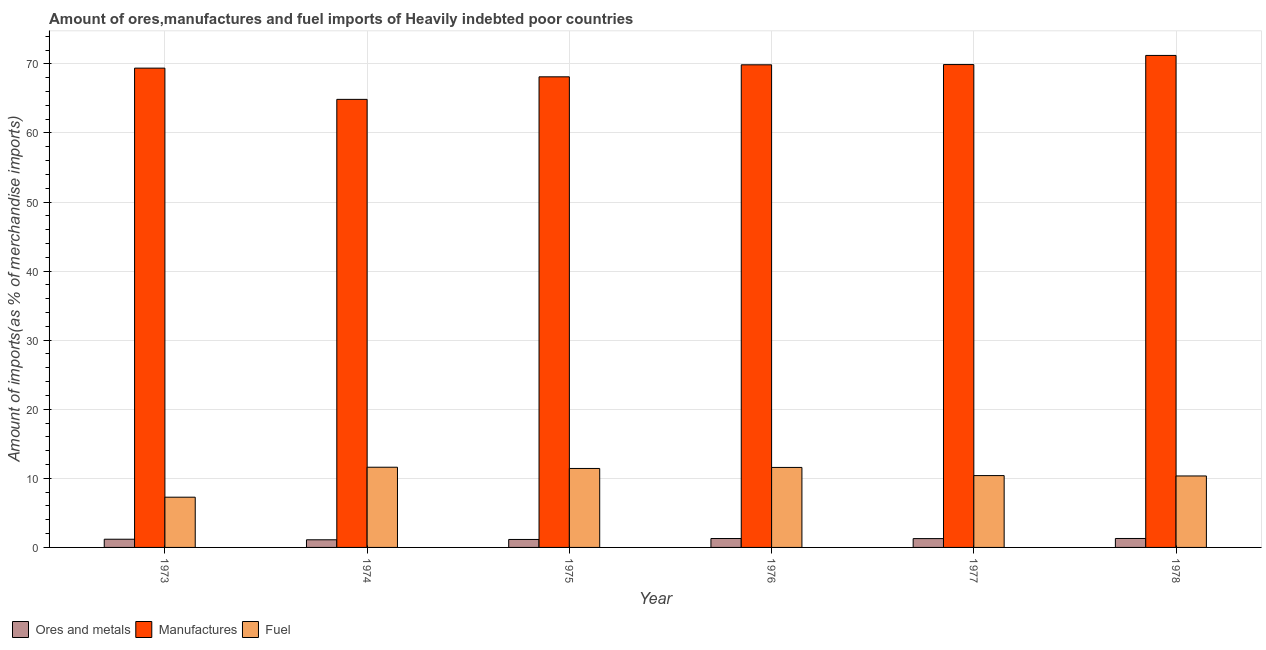How many groups of bars are there?
Provide a short and direct response. 6. Are the number of bars per tick equal to the number of legend labels?
Provide a succinct answer. Yes. How many bars are there on the 4th tick from the left?
Offer a very short reply. 3. How many bars are there on the 1st tick from the right?
Ensure brevity in your answer.  3. What is the label of the 6th group of bars from the left?
Offer a terse response. 1978. What is the percentage of fuel imports in 1976?
Give a very brief answer. 11.58. Across all years, what is the maximum percentage of manufactures imports?
Ensure brevity in your answer.  71.22. Across all years, what is the minimum percentage of ores and metals imports?
Keep it short and to the point. 1.11. In which year was the percentage of fuel imports maximum?
Keep it short and to the point. 1974. What is the total percentage of fuel imports in the graph?
Offer a very short reply. 62.64. What is the difference between the percentage of ores and metals imports in 1975 and that in 1976?
Provide a succinct answer. -0.13. What is the difference between the percentage of manufactures imports in 1978 and the percentage of ores and metals imports in 1974?
Offer a terse response. 6.36. What is the average percentage of manufactures imports per year?
Offer a very short reply. 68.89. In how many years, is the percentage of fuel imports greater than 24 %?
Your answer should be compact. 0. What is the ratio of the percentage of manufactures imports in 1973 to that in 1974?
Offer a terse response. 1.07. Is the difference between the percentage of ores and metals imports in 1974 and 1975 greater than the difference between the percentage of fuel imports in 1974 and 1975?
Provide a succinct answer. No. What is the difference between the highest and the second highest percentage of ores and metals imports?
Provide a succinct answer. 0.01. What is the difference between the highest and the lowest percentage of ores and metals imports?
Your answer should be very brief. 0.19. What does the 3rd bar from the left in 1975 represents?
Provide a succinct answer. Fuel. What does the 1st bar from the right in 1975 represents?
Your answer should be compact. Fuel. Is it the case that in every year, the sum of the percentage of ores and metals imports and percentage of manufactures imports is greater than the percentage of fuel imports?
Your answer should be very brief. Yes. How many bars are there?
Give a very brief answer. 18. Are all the bars in the graph horizontal?
Make the answer very short. No. How many years are there in the graph?
Keep it short and to the point. 6. Does the graph contain any zero values?
Offer a very short reply. No. How many legend labels are there?
Your response must be concise. 3. What is the title of the graph?
Give a very brief answer. Amount of ores,manufactures and fuel imports of Heavily indebted poor countries. What is the label or title of the Y-axis?
Give a very brief answer. Amount of imports(as % of merchandise imports). What is the Amount of imports(as % of merchandise imports) in Ores and metals in 1973?
Provide a succinct answer. 1.19. What is the Amount of imports(as % of merchandise imports) in Manufactures in 1973?
Make the answer very short. 69.38. What is the Amount of imports(as % of merchandise imports) in Fuel in 1973?
Your answer should be very brief. 7.27. What is the Amount of imports(as % of merchandise imports) of Ores and metals in 1974?
Your answer should be very brief. 1.11. What is the Amount of imports(as % of merchandise imports) of Manufactures in 1974?
Offer a terse response. 64.86. What is the Amount of imports(as % of merchandise imports) in Fuel in 1974?
Keep it short and to the point. 11.61. What is the Amount of imports(as % of merchandise imports) in Ores and metals in 1975?
Your answer should be compact. 1.15. What is the Amount of imports(as % of merchandise imports) in Manufactures in 1975?
Offer a terse response. 68.12. What is the Amount of imports(as % of merchandise imports) in Fuel in 1975?
Give a very brief answer. 11.43. What is the Amount of imports(as % of merchandise imports) in Ores and metals in 1976?
Your answer should be compact. 1.29. What is the Amount of imports(as % of merchandise imports) of Manufactures in 1976?
Your answer should be compact. 69.86. What is the Amount of imports(as % of merchandise imports) of Fuel in 1976?
Make the answer very short. 11.58. What is the Amount of imports(as % of merchandise imports) of Ores and metals in 1977?
Provide a succinct answer. 1.28. What is the Amount of imports(as % of merchandise imports) in Manufactures in 1977?
Offer a terse response. 69.9. What is the Amount of imports(as % of merchandise imports) in Fuel in 1977?
Your answer should be very brief. 10.4. What is the Amount of imports(as % of merchandise imports) of Ores and metals in 1978?
Ensure brevity in your answer.  1.29. What is the Amount of imports(as % of merchandise imports) of Manufactures in 1978?
Offer a terse response. 71.22. What is the Amount of imports(as % of merchandise imports) in Fuel in 1978?
Make the answer very short. 10.34. Across all years, what is the maximum Amount of imports(as % of merchandise imports) of Ores and metals?
Make the answer very short. 1.29. Across all years, what is the maximum Amount of imports(as % of merchandise imports) in Manufactures?
Offer a very short reply. 71.22. Across all years, what is the maximum Amount of imports(as % of merchandise imports) in Fuel?
Offer a very short reply. 11.61. Across all years, what is the minimum Amount of imports(as % of merchandise imports) in Ores and metals?
Your response must be concise. 1.11. Across all years, what is the minimum Amount of imports(as % of merchandise imports) in Manufactures?
Offer a very short reply. 64.86. Across all years, what is the minimum Amount of imports(as % of merchandise imports) of Fuel?
Keep it short and to the point. 7.27. What is the total Amount of imports(as % of merchandise imports) of Ores and metals in the graph?
Make the answer very short. 7.31. What is the total Amount of imports(as % of merchandise imports) in Manufactures in the graph?
Make the answer very short. 413.34. What is the total Amount of imports(as % of merchandise imports) in Fuel in the graph?
Give a very brief answer. 62.64. What is the difference between the Amount of imports(as % of merchandise imports) in Ores and metals in 1973 and that in 1974?
Keep it short and to the point. 0.08. What is the difference between the Amount of imports(as % of merchandise imports) of Manufactures in 1973 and that in 1974?
Make the answer very short. 4.52. What is the difference between the Amount of imports(as % of merchandise imports) of Fuel in 1973 and that in 1974?
Offer a very short reply. -4.34. What is the difference between the Amount of imports(as % of merchandise imports) in Ores and metals in 1973 and that in 1975?
Your response must be concise. 0.03. What is the difference between the Amount of imports(as % of merchandise imports) of Manufactures in 1973 and that in 1975?
Provide a short and direct response. 1.26. What is the difference between the Amount of imports(as % of merchandise imports) in Fuel in 1973 and that in 1975?
Your response must be concise. -4.16. What is the difference between the Amount of imports(as % of merchandise imports) of Manufactures in 1973 and that in 1976?
Give a very brief answer. -0.48. What is the difference between the Amount of imports(as % of merchandise imports) of Fuel in 1973 and that in 1976?
Your response must be concise. -4.31. What is the difference between the Amount of imports(as % of merchandise imports) in Ores and metals in 1973 and that in 1977?
Give a very brief answer. -0.09. What is the difference between the Amount of imports(as % of merchandise imports) of Manufactures in 1973 and that in 1977?
Provide a short and direct response. -0.52. What is the difference between the Amount of imports(as % of merchandise imports) of Fuel in 1973 and that in 1977?
Your answer should be very brief. -3.13. What is the difference between the Amount of imports(as % of merchandise imports) in Ores and metals in 1973 and that in 1978?
Offer a terse response. -0.11. What is the difference between the Amount of imports(as % of merchandise imports) of Manufactures in 1973 and that in 1978?
Your answer should be very brief. -1.84. What is the difference between the Amount of imports(as % of merchandise imports) of Fuel in 1973 and that in 1978?
Your answer should be compact. -3.07. What is the difference between the Amount of imports(as % of merchandise imports) in Ores and metals in 1974 and that in 1975?
Provide a short and direct response. -0.05. What is the difference between the Amount of imports(as % of merchandise imports) of Manufactures in 1974 and that in 1975?
Offer a very short reply. -3.26. What is the difference between the Amount of imports(as % of merchandise imports) in Fuel in 1974 and that in 1975?
Offer a very short reply. 0.18. What is the difference between the Amount of imports(as % of merchandise imports) in Ores and metals in 1974 and that in 1976?
Offer a terse response. -0.18. What is the difference between the Amount of imports(as % of merchandise imports) in Manufactures in 1974 and that in 1976?
Ensure brevity in your answer.  -5. What is the difference between the Amount of imports(as % of merchandise imports) in Fuel in 1974 and that in 1976?
Give a very brief answer. 0.03. What is the difference between the Amount of imports(as % of merchandise imports) of Ores and metals in 1974 and that in 1977?
Make the answer very short. -0.17. What is the difference between the Amount of imports(as % of merchandise imports) of Manufactures in 1974 and that in 1977?
Your answer should be very brief. -5.04. What is the difference between the Amount of imports(as % of merchandise imports) in Fuel in 1974 and that in 1977?
Provide a succinct answer. 1.21. What is the difference between the Amount of imports(as % of merchandise imports) in Ores and metals in 1974 and that in 1978?
Ensure brevity in your answer.  -0.19. What is the difference between the Amount of imports(as % of merchandise imports) of Manufactures in 1974 and that in 1978?
Your response must be concise. -6.36. What is the difference between the Amount of imports(as % of merchandise imports) of Fuel in 1974 and that in 1978?
Make the answer very short. 1.27. What is the difference between the Amount of imports(as % of merchandise imports) in Ores and metals in 1975 and that in 1976?
Your response must be concise. -0.13. What is the difference between the Amount of imports(as % of merchandise imports) in Manufactures in 1975 and that in 1976?
Offer a very short reply. -1.74. What is the difference between the Amount of imports(as % of merchandise imports) of Fuel in 1975 and that in 1976?
Ensure brevity in your answer.  -0.15. What is the difference between the Amount of imports(as % of merchandise imports) in Ores and metals in 1975 and that in 1977?
Offer a terse response. -0.12. What is the difference between the Amount of imports(as % of merchandise imports) in Manufactures in 1975 and that in 1977?
Keep it short and to the point. -1.77. What is the difference between the Amount of imports(as % of merchandise imports) in Ores and metals in 1975 and that in 1978?
Provide a short and direct response. -0.14. What is the difference between the Amount of imports(as % of merchandise imports) in Manufactures in 1975 and that in 1978?
Ensure brevity in your answer.  -3.1. What is the difference between the Amount of imports(as % of merchandise imports) of Fuel in 1975 and that in 1978?
Keep it short and to the point. 1.09. What is the difference between the Amount of imports(as % of merchandise imports) of Ores and metals in 1976 and that in 1977?
Provide a succinct answer. 0.01. What is the difference between the Amount of imports(as % of merchandise imports) in Manufactures in 1976 and that in 1977?
Provide a succinct answer. -0.03. What is the difference between the Amount of imports(as % of merchandise imports) of Fuel in 1976 and that in 1977?
Provide a succinct answer. 1.18. What is the difference between the Amount of imports(as % of merchandise imports) of Ores and metals in 1976 and that in 1978?
Offer a very short reply. -0.01. What is the difference between the Amount of imports(as % of merchandise imports) in Manufactures in 1976 and that in 1978?
Provide a short and direct response. -1.36. What is the difference between the Amount of imports(as % of merchandise imports) in Fuel in 1976 and that in 1978?
Offer a very short reply. 1.23. What is the difference between the Amount of imports(as % of merchandise imports) in Ores and metals in 1977 and that in 1978?
Offer a terse response. -0.02. What is the difference between the Amount of imports(as % of merchandise imports) of Manufactures in 1977 and that in 1978?
Make the answer very short. -1.32. What is the difference between the Amount of imports(as % of merchandise imports) in Fuel in 1977 and that in 1978?
Keep it short and to the point. 0.06. What is the difference between the Amount of imports(as % of merchandise imports) of Ores and metals in 1973 and the Amount of imports(as % of merchandise imports) of Manufactures in 1974?
Ensure brevity in your answer.  -63.67. What is the difference between the Amount of imports(as % of merchandise imports) in Ores and metals in 1973 and the Amount of imports(as % of merchandise imports) in Fuel in 1974?
Your answer should be very brief. -10.42. What is the difference between the Amount of imports(as % of merchandise imports) in Manufactures in 1973 and the Amount of imports(as % of merchandise imports) in Fuel in 1974?
Provide a succinct answer. 57.77. What is the difference between the Amount of imports(as % of merchandise imports) in Ores and metals in 1973 and the Amount of imports(as % of merchandise imports) in Manufactures in 1975?
Ensure brevity in your answer.  -66.93. What is the difference between the Amount of imports(as % of merchandise imports) in Ores and metals in 1973 and the Amount of imports(as % of merchandise imports) in Fuel in 1975?
Your response must be concise. -10.24. What is the difference between the Amount of imports(as % of merchandise imports) in Manufactures in 1973 and the Amount of imports(as % of merchandise imports) in Fuel in 1975?
Ensure brevity in your answer.  57.95. What is the difference between the Amount of imports(as % of merchandise imports) in Ores and metals in 1973 and the Amount of imports(as % of merchandise imports) in Manufactures in 1976?
Your answer should be very brief. -68.67. What is the difference between the Amount of imports(as % of merchandise imports) in Ores and metals in 1973 and the Amount of imports(as % of merchandise imports) in Fuel in 1976?
Provide a succinct answer. -10.39. What is the difference between the Amount of imports(as % of merchandise imports) in Manufactures in 1973 and the Amount of imports(as % of merchandise imports) in Fuel in 1976?
Give a very brief answer. 57.8. What is the difference between the Amount of imports(as % of merchandise imports) of Ores and metals in 1973 and the Amount of imports(as % of merchandise imports) of Manufactures in 1977?
Your answer should be compact. -68.71. What is the difference between the Amount of imports(as % of merchandise imports) in Ores and metals in 1973 and the Amount of imports(as % of merchandise imports) in Fuel in 1977?
Your answer should be very brief. -9.21. What is the difference between the Amount of imports(as % of merchandise imports) of Manufactures in 1973 and the Amount of imports(as % of merchandise imports) of Fuel in 1977?
Ensure brevity in your answer.  58.98. What is the difference between the Amount of imports(as % of merchandise imports) of Ores and metals in 1973 and the Amount of imports(as % of merchandise imports) of Manufactures in 1978?
Ensure brevity in your answer.  -70.03. What is the difference between the Amount of imports(as % of merchandise imports) of Ores and metals in 1973 and the Amount of imports(as % of merchandise imports) of Fuel in 1978?
Your answer should be very brief. -9.16. What is the difference between the Amount of imports(as % of merchandise imports) in Manufactures in 1973 and the Amount of imports(as % of merchandise imports) in Fuel in 1978?
Provide a short and direct response. 59.04. What is the difference between the Amount of imports(as % of merchandise imports) of Ores and metals in 1974 and the Amount of imports(as % of merchandise imports) of Manufactures in 1975?
Provide a succinct answer. -67.02. What is the difference between the Amount of imports(as % of merchandise imports) in Ores and metals in 1974 and the Amount of imports(as % of merchandise imports) in Fuel in 1975?
Give a very brief answer. -10.32. What is the difference between the Amount of imports(as % of merchandise imports) in Manufactures in 1974 and the Amount of imports(as % of merchandise imports) in Fuel in 1975?
Provide a short and direct response. 53.43. What is the difference between the Amount of imports(as % of merchandise imports) in Ores and metals in 1974 and the Amount of imports(as % of merchandise imports) in Manufactures in 1976?
Make the answer very short. -68.76. What is the difference between the Amount of imports(as % of merchandise imports) of Ores and metals in 1974 and the Amount of imports(as % of merchandise imports) of Fuel in 1976?
Your answer should be compact. -10.47. What is the difference between the Amount of imports(as % of merchandise imports) in Manufactures in 1974 and the Amount of imports(as % of merchandise imports) in Fuel in 1976?
Ensure brevity in your answer.  53.28. What is the difference between the Amount of imports(as % of merchandise imports) in Ores and metals in 1974 and the Amount of imports(as % of merchandise imports) in Manufactures in 1977?
Your answer should be compact. -68.79. What is the difference between the Amount of imports(as % of merchandise imports) of Ores and metals in 1974 and the Amount of imports(as % of merchandise imports) of Fuel in 1977?
Keep it short and to the point. -9.29. What is the difference between the Amount of imports(as % of merchandise imports) in Manufactures in 1974 and the Amount of imports(as % of merchandise imports) in Fuel in 1977?
Your answer should be compact. 54.46. What is the difference between the Amount of imports(as % of merchandise imports) of Ores and metals in 1974 and the Amount of imports(as % of merchandise imports) of Manufactures in 1978?
Keep it short and to the point. -70.11. What is the difference between the Amount of imports(as % of merchandise imports) in Ores and metals in 1974 and the Amount of imports(as % of merchandise imports) in Fuel in 1978?
Provide a succinct answer. -9.24. What is the difference between the Amount of imports(as % of merchandise imports) of Manufactures in 1974 and the Amount of imports(as % of merchandise imports) of Fuel in 1978?
Offer a terse response. 54.51. What is the difference between the Amount of imports(as % of merchandise imports) of Ores and metals in 1975 and the Amount of imports(as % of merchandise imports) of Manufactures in 1976?
Your response must be concise. -68.71. What is the difference between the Amount of imports(as % of merchandise imports) in Ores and metals in 1975 and the Amount of imports(as % of merchandise imports) in Fuel in 1976?
Provide a succinct answer. -10.43. What is the difference between the Amount of imports(as % of merchandise imports) in Manufactures in 1975 and the Amount of imports(as % of merchandise imports) in Fuel in 1976?
Your response must be concise. 56.54. What is the difference between the Amount of imports(as % of merchandise imports) in Ores and metals in 1975 and the Amount of imports(as % of merchandise imports) in Manufactures in 1977?
Ensure brevity in your answer.  -68.74. What is the difference between the Amount of imports(as % of merchandise imports) in Ores and metals in 1975 and the Amount of imports(as % of merchandise imports) in Fuel in 1977?
Give a very brief answer. -9.25. What is the difference between the Amount of imports(as % of merchandise imports) of Manufactures in 1975 and the Amount of imports(as % of merchandise imports) of Fuel in 1977?
Your response must be concise. 57.72. What is the difference between the Amount of imports(as % of merchandise imports) of Ores and metals in 1975 and the Amount of imports(as % of merchandise imports) of Manufactures in 1978?
Give a very brief answer. -70.07. What is the difference between the Amount of imports(as % of merchandise imports) of Ores and metals in 1975 and the Amount of imports(as % of merchandise imports) of Fuel in 1978?
Offer a terse response. -9.19. What is the difference between the Amount of imports(as % of merchandise imports) in Manufactures in 1975 and the Amount of imports(as % of merchandise imports) in Fuel in 1978?
Your answer should be compact. 57.78. What is the difference between the Amount of imports(as % of merchandise imports) of Ores and metals in 1976 and the Amount of imports(as % of merchandise imports) of Manufactures in 1977?
Offer a terse response. -68.61. What is the difference between the Amount of imports(as % of merchandise imports) in Ores and metals in 1976 and the Amount of imports(as % of merchandise imports) in Fuel in 1977?
Your answer should be compact. -9.11. What is the difference between the Amount of imports(as % of merchandise imports) in Manufactures in 1976 and the Amount of imports(as % of merchandise imports) in Fuel in 1977?
Provide a succinct answer. 59.46. What is the difference between the Amount of imports(as % of merchandise imports) of Ores and metals in 1976 and the Amount of imports(as % of merchandise imports) of Manufactures in 1978?
Your answer should be compact. -69.93. What is the difference between the Amount of imports(as % of merchandise imports) in Ores and metals in 1976 and the Amount of imports(as % of merchandise imports) in Fuel in 1978?
Offer a terse response. -9.06. What is the difference between the Amount of imports(as % of merchandise imports) of Manufactures in 1976 and the Amount of imports(as % of merchandise imports) of Fuel in 1978?
Provide a succinct answer. 59.52. What is the difference between the Amount of imports(as % of merchandise imports) in Ores and metals in 1977 and the Amount of imports(as % of merchandise imports) in Manufactures in 1978?
Ensure brevity in your answer.  -69.94. What is the difference between the Amount of imports(as % of merchandise imports) in Ores and metals in 1977 and the Amount of imports(as % of merchandise imports) in Fuel in 1978?
Provide a succinct answer. -9.07. What is the difference between the Amount of imports(as % of merchandise imports) in Manufactures in 1977 and the Amount of imports(as % of merchandise imports) in Fuel in 1978?
Offer a terse response. 59.55. What is the average Amount of imports(as % of merchandise imports) in Ores and metals per year?
Give a very brief answer. 1.22. What is the average Amount of imports(as % of merchandise imports) in Manufactures per year?
Your response must be concise. 68.89. What is the average Amount of imports(as % of merchandise imports) in Fuel per year?
Make the answer very short. 10.44. In the year 1973, what is the difference between the Amount of imports(as % of merchandise imports) in Ores and metals and Amount of imports(as % of merchandise imports) in Manufactures?
Give a very brief answer. -68.19. In the year 1973, what is the difference between the Amount of imports(as % of merchandise imports) in Ores and metals and Amount of imports(as % of merchandise imports) in Fuel?
Your response must be concise. -6.08. In the year 1973, what is the difference between the Amount of imports(as % of merchandise imports) in Manufactures and Amount of imports(as % of merchandise imports) in Fuel?
Your response must be concise. 62.11. In the year 1974, what is the difference between the Amount of imports(as % of merchandise imports) of Ores and metals and Amount of imports(as % of merchandise imports) of Manufactures?
Your response must be concise. -63.75. In the year 1974, what is the difference between the Amount of imports(as % of merchandise imports) of Ores and metals and Amount of imports(as % of merchandise imports) of Fuel?
Ensure brevity in your answer.  -10.51. In the year 1974, what is the difference between the Amount of imports(as % of merchandise imports) in Manufactures and Amount of imports(as % of merchandise imports) in Fuel?
Keep it short and to the point. 53.25. In the year 1975, what is the difference between the Amount of imports(as % of merchandise imports) of Ores and metals and Amount of imports(as % of merchandise imports) of Manufactures?
Provide a short and direct response. -66.97. In the year 1975, what is the difference between the Amount of imports(as % of merchandise imports) of Ores and metals and Amount of imports(as % of merchandise imports) of Fuel?
Provide a succinct answer. -10.28. In the year 1975, what is the difference between the Amount of imports(as % of merchandise imports) in Manufactures and Amount of imports(as % of merchandise imports) in Fuel?
Your response must be concise. 56.69. In the year 1976, what is the difference between the Amount of imports(as % of merchandise imports) in Ores and metals and Amount of imports(as % of merchandise imports) in Manufactures?
Offer a very short reply. -68.57. In the year 1976, what is the difference between the Amount of imports(as % of merchandise imports) of Ores and metals and Amount of imports(as % of merchandise imports) of Fuel?
Your answer should be very brief. -10.29. In the year 1976, what is the difference between the Amount of imports(as % of merchandise imports) of Manufactures and Amount of imports(as % of merchandise imports) of Fuel?
Your answer should be very brief. 58.28. In the year 1977, what is the difference between the Amount of imports(as % of merchandise imports) of Ores and metals and Amount of imports(as % of merchandise imports) of Manufactures?
Give a very brief answer. -68.62. In the year 1977, what is the difference between the Amount of imports(as % of merchandise imports) in Ores and metals and Amount of imports(as % of merchandise imports) in Fuel?
Provide a succinct answer. -9.12. In the year 1977, what is the difference between the Amount of imports(as % of merchandise imports) in Manufactures and Amount of imports(as % of merchandise imports) in Fuel?
Your answer should be very brief. 59.5. In the year 1978, what is the difference between the Amount of imports(as % of merchandise imports) of Ores and metals and Amount of imports(as % of merchandise imports) of Manufactures?
Provide a succinct answer. -69.93. In the year 1978, what is the difference between the Amount of imports(as % of merchandise imports) in Ores and metals and Amount of imports(as % of merchandise imports) in Fuel?
Your answer should be very brief. -9.05. In the year 1978, what is the difference between the Amount of imports(as % of merchandise imports) of Manufactures and Amount of imports(as % of merchandise imports) of Fuel?
Your response must be concise. 60.88. What is the ratio of the Amount of imports(as % of merchandise imports) in Ores and metals in 1973 to that in 1974?
Keep it short and to the point. 1.07. What is the ratio of the Amount of imports(as % of merchandise imports) in Manufactures in 1973 to that in 1974?
Keep it short and to the point. 1.07. What is the ratio of the Amount of imports(as % of merchandise imports) in Fuel in 1973 to that in 1974?
Offer a terse response. 0.63. What is the ratio of the Amount of imports(as % of merchandise imports) in Ores and metals in 1973 to that in 1975?
Give a very brief answer. 1.03. What is the ratio of the Amount of imports(as % of merchandise imports) of Manufactures in 1973 to that in 1975?
Your answer should be compact. 1.02. What is the ratio of the Amount of imports(as % of merchandise imports) in Fuel in 1973 to that in 1975?
Offer a terse response. 0.64. What is the ratio of the Amount of imports(as % of merchandise imports) in Ores and metals in 1973 to that in 1976?
Keep it short and to the point. 0.92. What is the ratio of the Amount of imports(as % of merchandise imports) in Fuel in 1973 to that in 1976?
Give a very brief answer. 0.63. What is the ratio of the Amount of imports(as % of merchandise imports) in Ores and metals in 1973 to that in 1977?
Ensure brevity in your answer.  0.93. What is the ratio of the Amount of imports(as % of merchandise imports) in Fuel in 1973 to that in 1977?
Provide a short and direct response. 0.7. What is the ratio of the Amount of imports(as % of merchandise imports) of Ores and metals in 1973 to that in 1978?
Offer a terse response. 0.92. What is the ratio of the Amount of imports(as % of merchandise imports) in Manufactures in 1973 to that in 1978?
Your answer should be very brief. 0.97. What is the ratio of the Amount of imports(as % of merchandise imports) in Fuel in 1973 to that in 1978?
Provide a succinct answer. 0.7. What is the ratio of the Amount of imports(as % of merchandise imports) of Ores and metals in 1974 to that in 1975?
Make the answer very short. 0.96. What is the ratio of the Amount of imports(as % of merchandise imports) of Manufactures in 1974 to that in 1975?
Keep it short and to the point. 0.95. What is the ratio of the Amount of imports(as % of merchandise imports) of Fuel in 1974 to that in 1975?
Ensure brevity in your answer.  1.02. What is the ratio of the Amount of imports(as % of merchandise imports) in Ores and metals in 1974 to that in 1976?
Give a very brief answer. 0.86. What is the ratio of the Amount of imports(as % of merchandise imports) of Manufactures in 1974 to that in 1976?
Offer a very short reply. 0.93. What is the ratio of the Amount of imports(as % of merchandise imports) of Ores and metals in 1974 to that in 1977?
Offer a very short reply. 0.86. What is the ratio of the Amount of imports(as % of merchandise imports) in Manufactures in 1974 to that in 1977?
Provide a succinct answer. 0.93. What is the ratio of the Amount of imports(as % of merchandise imports) in Fuel in 1974 to that in 1977?
Your answer should be compact. 1.12. What is the ratio of the Amount of imports(as % of merchandise imports) in Ores and metals in 1974 to that in 1978?
Your answer should be compact. 0.85. What is the ratio of the Amount of imports(as % of merchandise imports) of Manufactures in 1974 to that in 1978?
Offer a terse response. 0.91. What is the ratio of the Amount of imports(as % of merchandise imports) in Fuel in 1974 to that in 1978?
Ensure brevity in your answer.  1.12. What is the ratio of the Amount of imports(as % of merchandise imports) in Ores and metals in 1975 to that in 1976?
Keep it short and to the point. 0.9. What is the ratio of the Amount of imports(as % of merchandise imports) in Manufactures in 1975 to that in 1976?
Offer a very short reply. 0.98. What is the ratio of the Amount of imports(as % of merchandise imports) of Fuel in 1975 to that in 1976?
Offer a terse response. 0.99. What is the ratio of the Amount of imports(as % of merchandise imports) of Ores and metals in 1975 to that in 1977?
Offer a very short reply. 0.9. What is the ratio of the Amount of imports(as % of merchandise imports) of Manufactures in 1975 to that in 1977?
Provide a succinct answer. 0.97. What is the ratio of the Amount of imports(as % of merchandise imports) in Fuel in 1975 to that in 1977?
Offer a terse response. 1.1. What is the ratio of the Amount of imports(as % of merchandise imports) in Ores and metals in 1975 to that in 1978?
Offer a terse response. 0.89. What is the ratio of the Amount of imports(as % of merchandise imports) in Manufactures in 1975 to that in 1978?
Make the answer very short. 0.96. What is the ratio of the Amount of imports(as % of merchandise imports) of Fuel in 1975 to that in 1978?
Keep it short and to the point. 1.1. What is the ratio of the Amount of imports(as % of merchandise imports) in Ores and metals in 1976 to that in 1977?
Provide a succinct answer. 1.01. What is the ratio of the Amount of imports(as % of merchandise imports) in Fuel in 1976 to that in 1977?
Give a very brief answer. 1.11. What is the ratio of the Amount of imports(as % of merchandise imports) in Ores and metals in 1976 to that in 1978?
Your answer should be compact. 0.99. What is the ratio of the Amount of imports(as % of merchandise imports) in Manufactures in 1976 to that in 1978?
Provide a short and direct response. 0.98. What is the ratio of the Amount of imports(as % of merchandise imports) of Fuel in 1976 to that in 1978?
Make the answer very short. 1.12. What is the ratio of the Amount of imports(as % of merchandise imports) in Ores and metals in 1977 to that in 1978?
Offer a very short reply. 0.99. What is the ratio of the Amount of imports(as % of merchandise imports) in Manufactures in 1977 to that in 1978?
Ensure brevity in your answer.  0.98. What is the ratio of the Amount of imports(as % of merchandise imports) of Fuel in 1977 to that in 1978?
Your response must be concise. 1.01. What is the difference between the highest and the second highest Amount of imports(as % of merchandise imports) of Ores and metals?
Keep it short and to the point. 0.01. What is the difference between the highest and the second highest Amount of imports(as % of merchandise imports) of Manufactures?
Ensure brevity in your answer.  1.32. What is the difference between the highest and the second highest Amount of imports(as % of merchandise imports) in Fuel?
Ensure brevity in your answer.  0.03. What is the difference between the highest and the lowest Amount of imports(as % of merchandise imports) of Ores and metals?
Keep it short and to the point. 0.19. What is the difference between the highest and the lowest Amount of imports(as % of merchandise imports) of Manufactures?
Provide a succinct answer. 6.36. What is the difference between the highest and the lowest Amount of imports(as % of merchandise imports) of Fuel?
Your answer should be very brief. 4.34. 